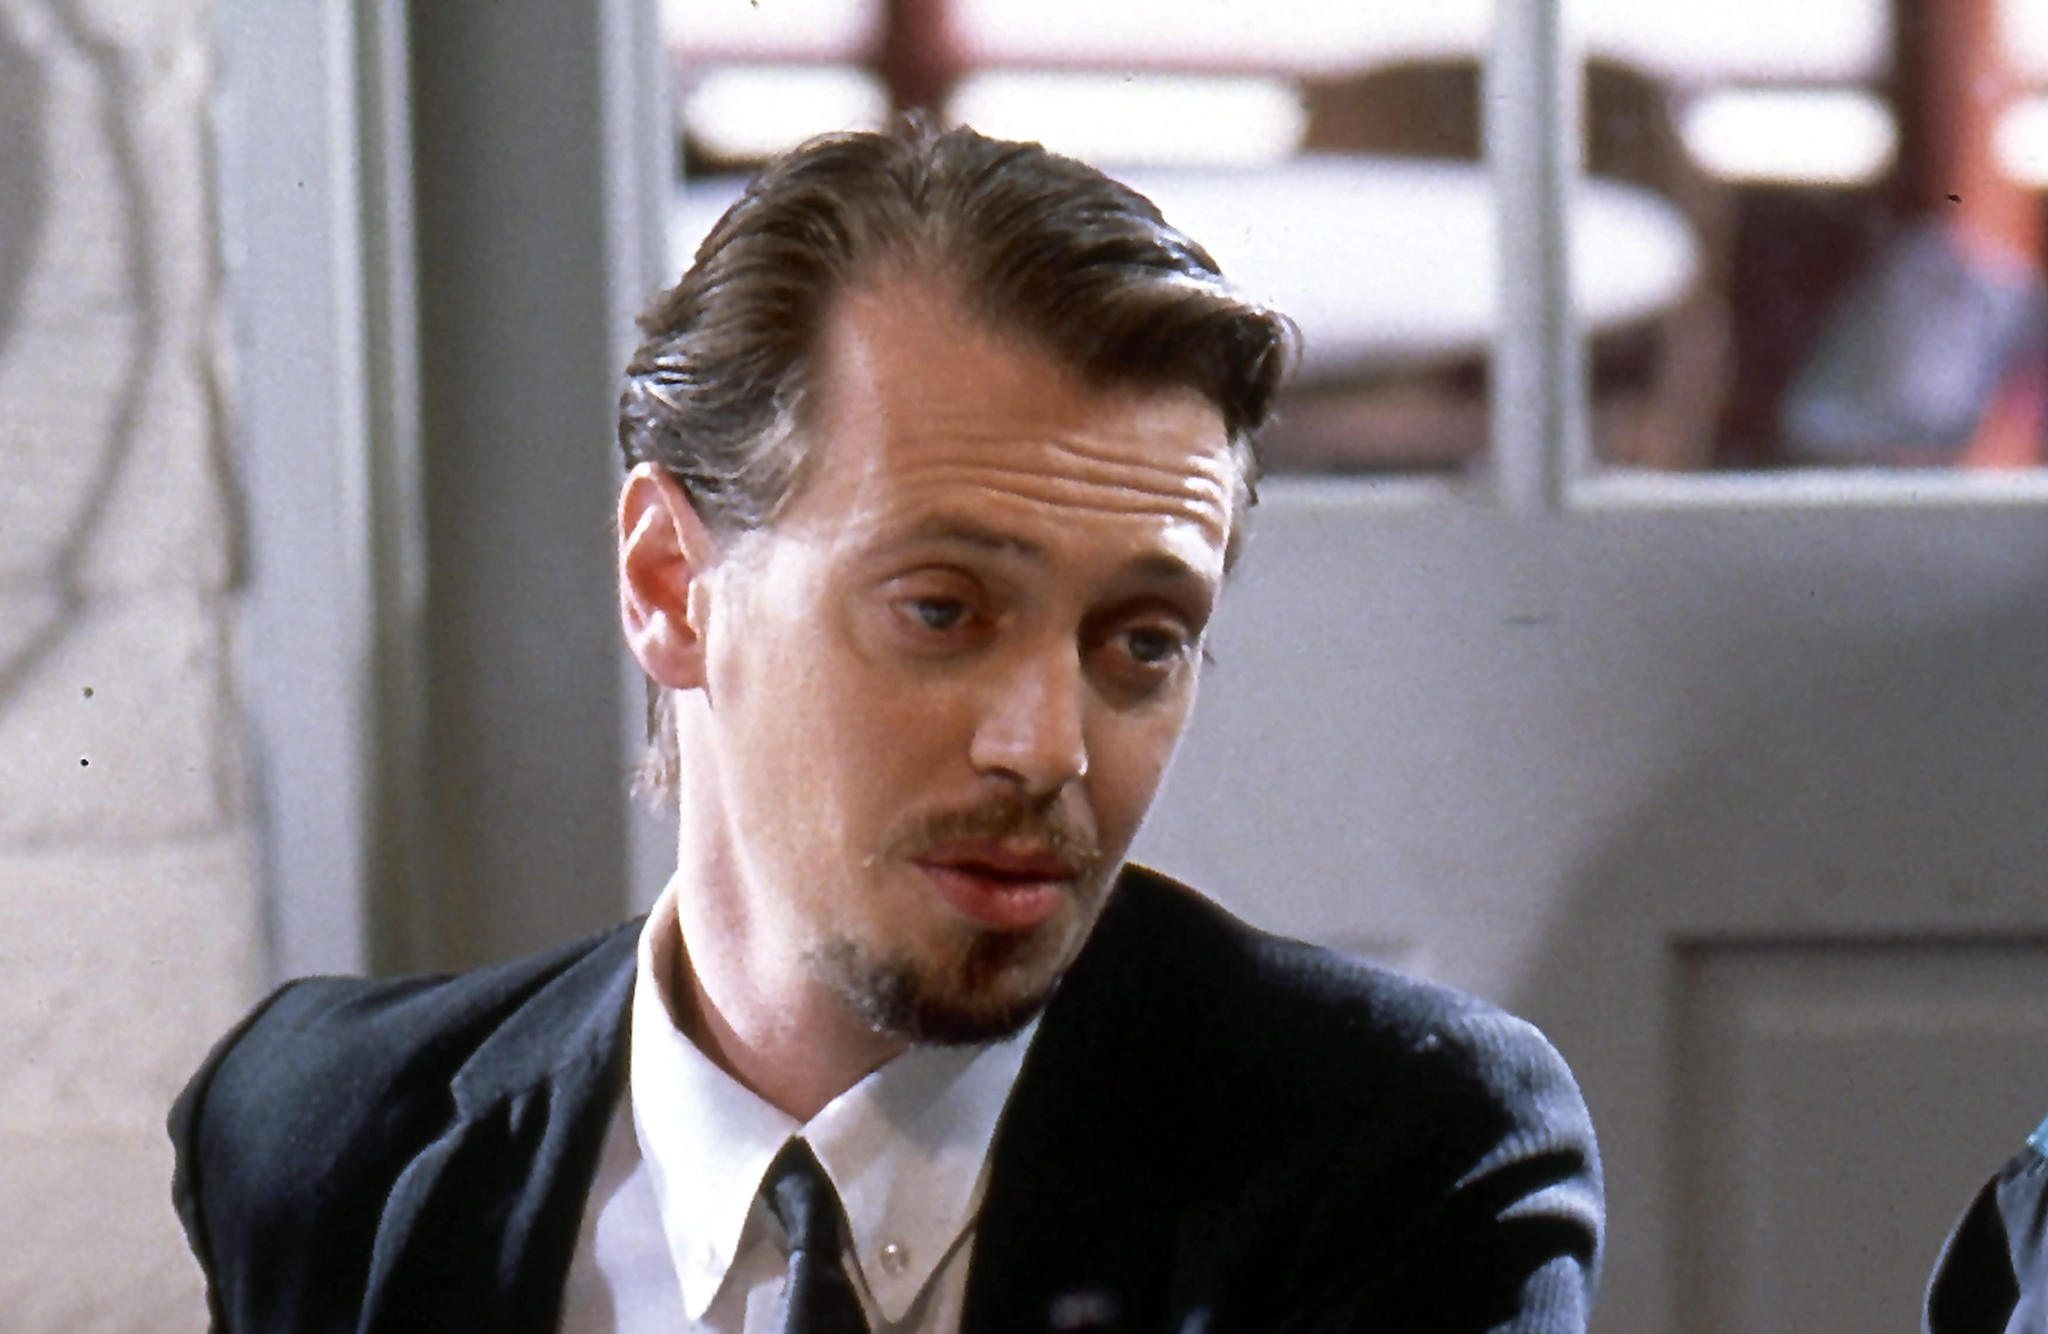This character appears to be plotting something. Create a short dialogue as if he is discussing his plans with an accomplice. Mr. Pink: "We need to be in and out in under five minutes. No mistakes, no loose ends."
Accomplice: "Got it. What about the getaway?"
Mr. Pink: "The car will be waiting at the north exit. Make sure you memorize the layout, no second guesses."
Accomplice: "And the guards?"
Mr. Pink: "Leave them to me. Just stick to the plan, and we'll be fine." 